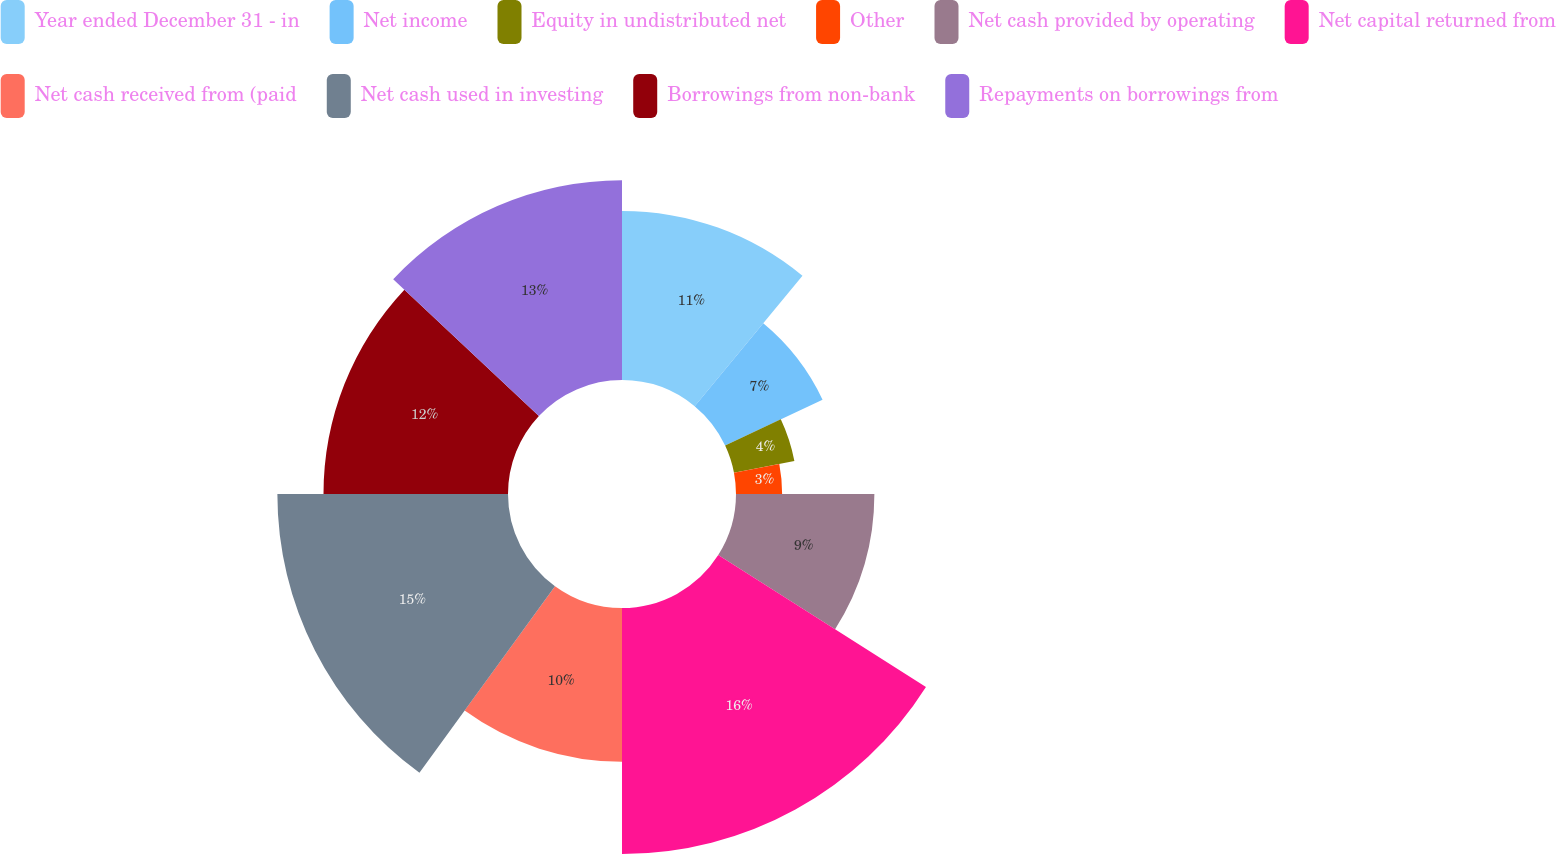Convert chart. <chart><loc_0><loc_0><loc_500><loc_500><pie_chart><fcel>Year ended December 31 - in<fcel>Net income<fcel>Equity in undistributed net<fcel>Other<fcel>Net cash provided by operating<fcel>Net capital returned from<fcel>Net cash received from (paid<fcel>Net cash used in investing<fcel>Borrowings from non-bank<fcel>Repayments on borrowings from<nl><fcel>11.0%<fcel>7.0%<fcel>4.0%<fcel>3.0%<fcel>9.0%<fcel>16.0%<fcel>10.0%<fcel>15.0%<fcel>12.0%<fcel>13.0%<nl></chart> 